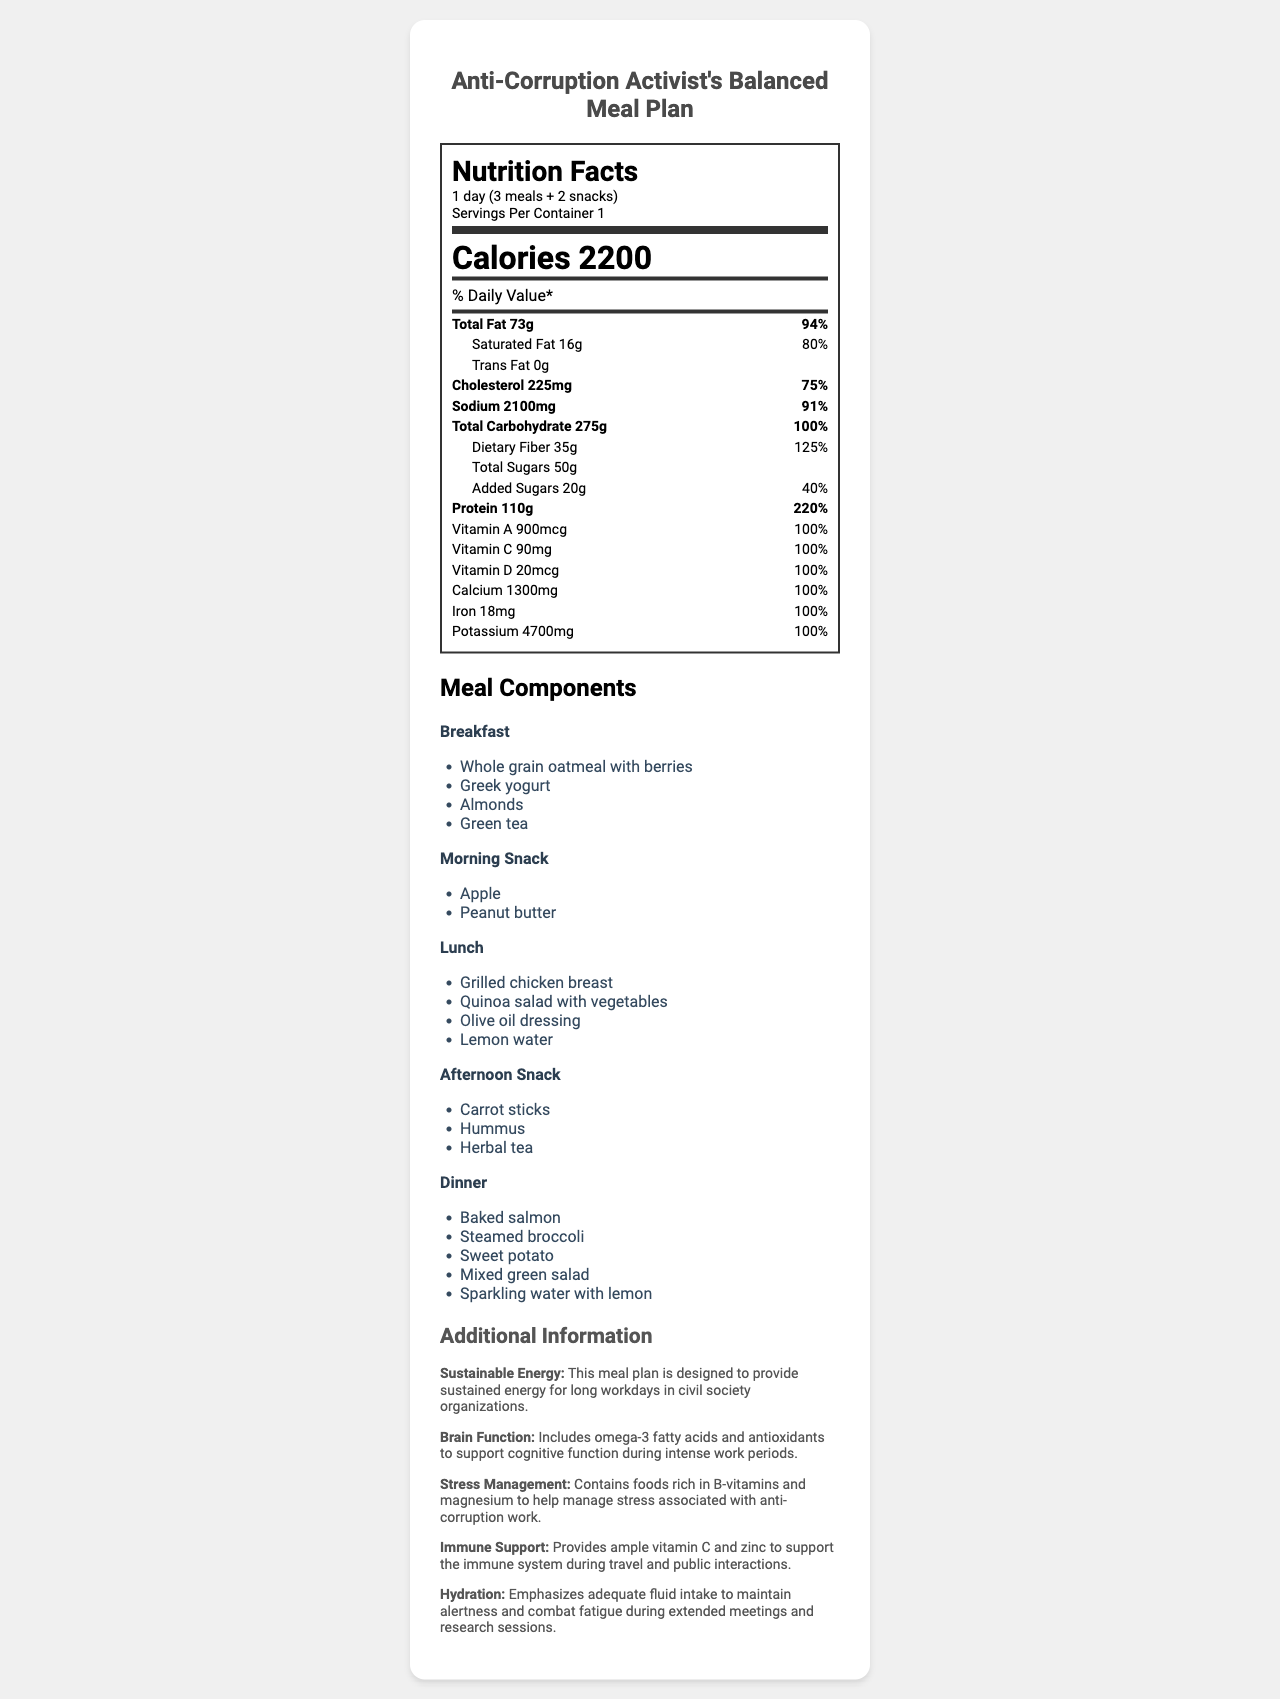what is the total calorie count of the meal plan? The document states that the meal plan contains 2200 calories.
Answer: 2200 how much saturated fat is in the meal plan? The document shows that the total amount of saturated fat is 16 grams.
Answer: 16g What percentage of the daily value does protein provide? The nutrition facts state that protein contributes 220% to the daily value.
Answer: 220% Which component has the highest daily value percentage? A. Total Carbohydrate B. Dietary Fiber C. Sodium Dietary Fiber has the highest daily value percentage at 125%.
Answer: B does the meal plan contain any trans fat? The document indicates that the meal plan contains 0 grams of trans fat.
Answer: No What are the key components in the breakfast meal? The breakfast section lists these items as the meal components.
Answer: Whole grain oatmeal with berries, Greek yogurt, Almonds, Green tea how much dietary fiber does the meal plan contain? The meal plan contains 35 grams of dietary fiber, as shown in the document.
Answer: 35g Does the meal plan support cognitive function? The additional information section mentions that the meal plan includes omega-3 fatty acids and antioxidants to support cognitive function.
Answer: Yes What is the sodium content in the meal plan? The document states that there are 2100 milligrams of sodium in the meal plan.
Answer: 2100mg which meal includes "Grilled chicken breast"? A. Breakfast B. Lunch C. Dinner D. Morning Snack The "Grilled chicken breast" is listed under Lunch.
Answer: B describe the overall purpose of the meal plan The meal plan specifies components for breakfast, snacks, lunch, and dinner. It highlights key nutritional information and additional benefits like supporting brain function, stress management, and immune support.
Answer: The meal plan is designed to provide a balanced diet that sustains energy, supports cognitive function, manages stress, supports the immune system, and emphasizes hydration for individuals working long hours in civil society organizations fighting against corruption. how many total sugars does the meal plan contain? The nutrition facts state the meal plan contains 50 grams of total sugars.
Answer: 50g What food item is part of the afternoon snack? The document lists "Carrot sticks" as a component of the afternoon snack.
Answer: Carrot sticks does the meal plan provide enough information to track micronutrient intake? The document does provide information on several vitamins and minerals, but it doesn't cover all micronutrients required.
Answer: No What percentage of the daily value for calcium is met by the meal plan? The nutrition facts indicate that the calcium in the meal plan meets 100% of the daily value.
Answer: 100% what is the main beverage for dinner in the meal plan? Under the dinner section, "Sparkling water with lemon" is listed as the beverage.
Answer: Sparkling water with lemon 